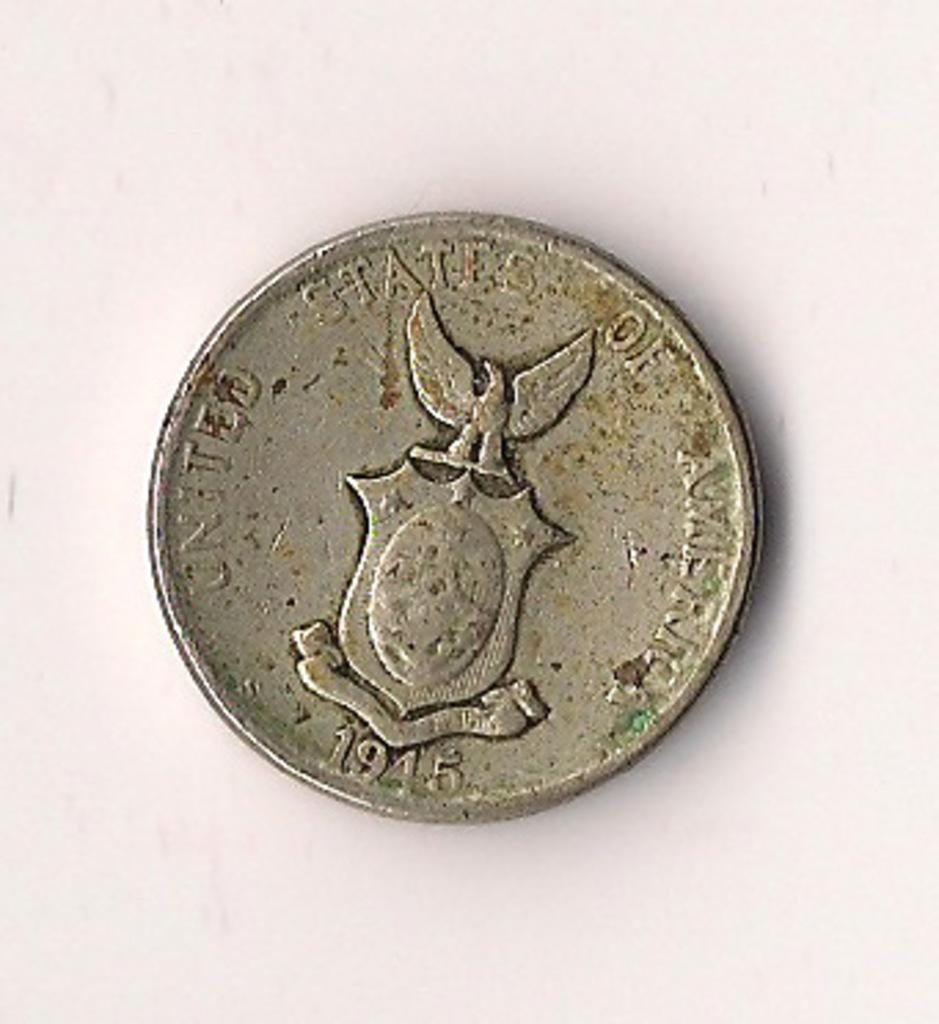What object is the main subject of the image? There is a silver coin in the image. What can be seen on the surface of the coin? The coin has text, numerical numbers, and a symbol on it. What is the color of the surface the coin is placed on? The coin is placed on a white surface. What type of authority figure is depicted on the coin? There is no authority figure depicted on the coin; it only has text, numerical numbers, and a symbol. Can you tell me how many forks are present on the coin? There are no forks present on the coin; it only has text, numerical numbers, and a symbol. 